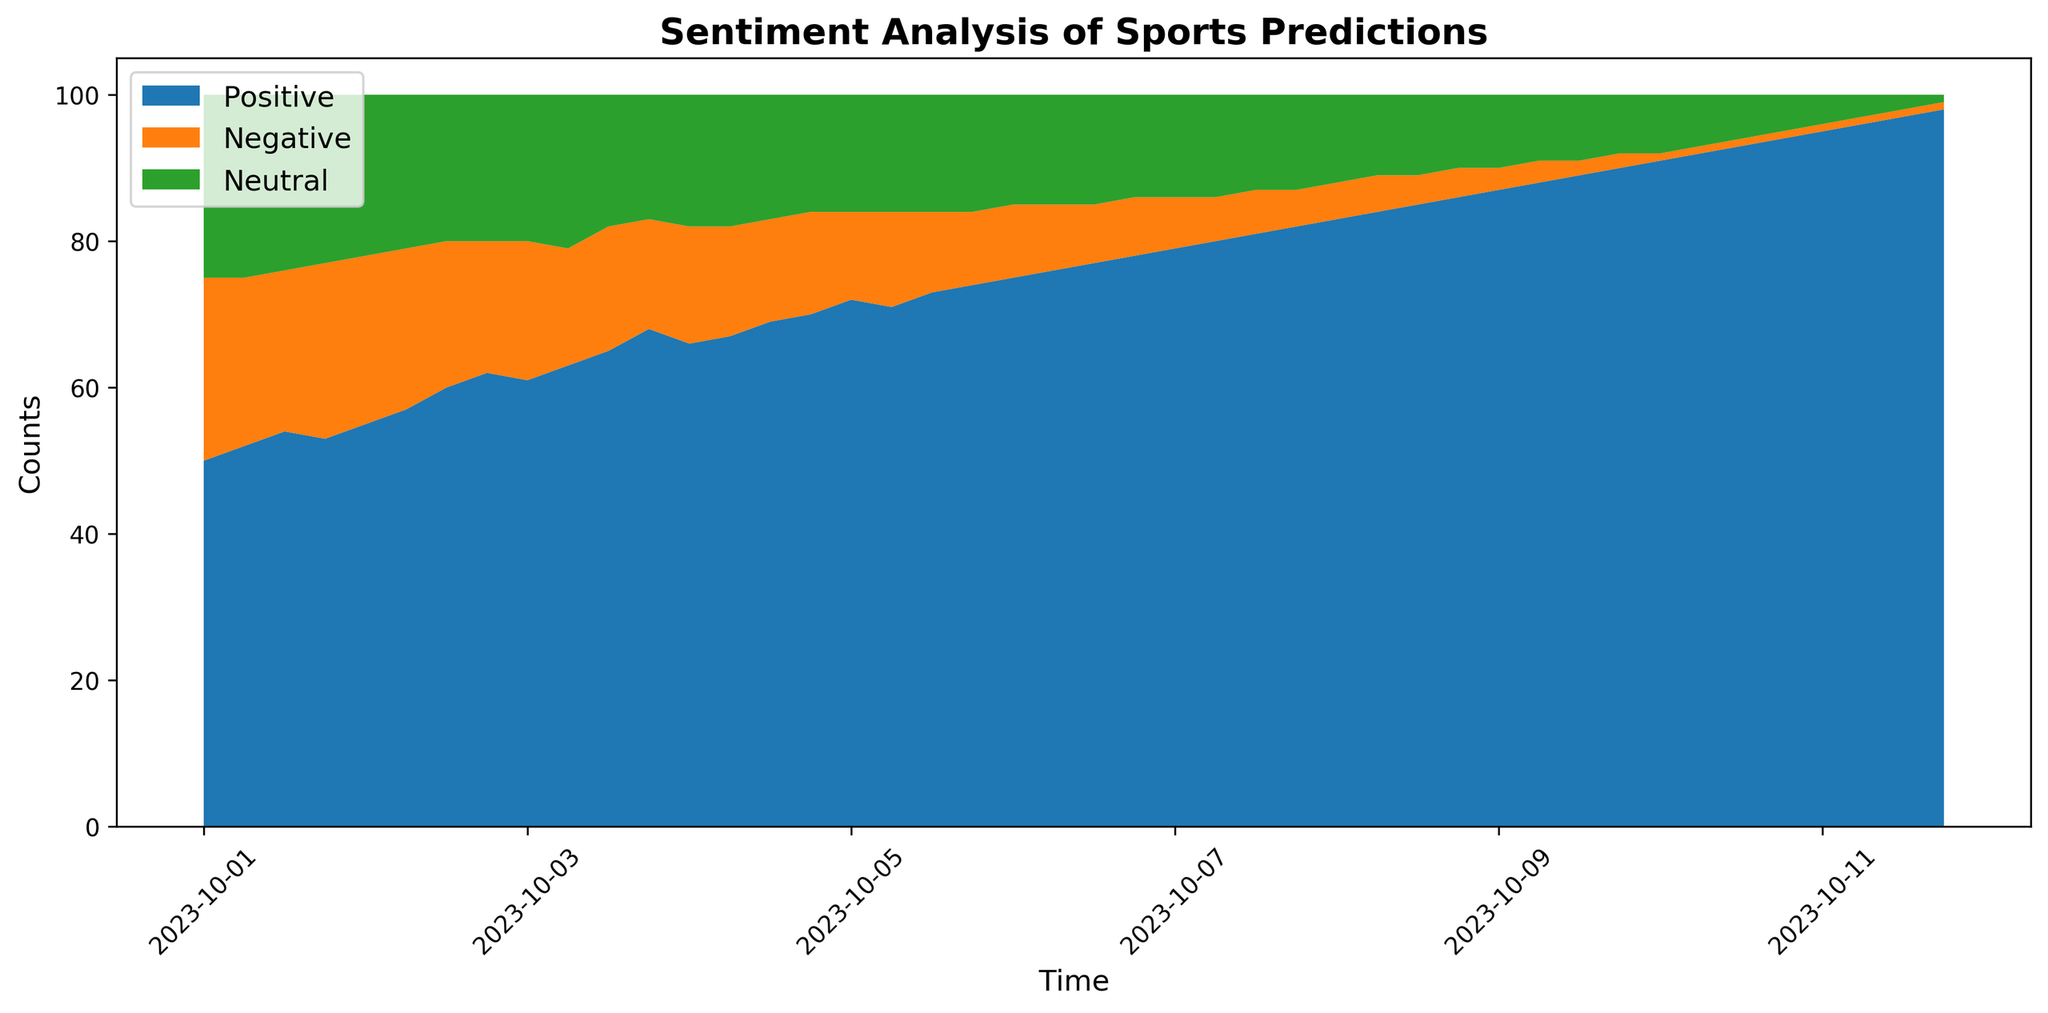What is the overall trend of positive sentiment from October 1 to October 11? The positive sentiment shows a steady increase over time from October 1st to October 11th. You can see that the area representing positive sentiment grows continuously without any significant drops.
Answer: A steady increase Which sentiment (positive, negative, or neutral) shows the least amount of change over time? The neutral sentiment area does not show significant changes and remains relatively constant when compared to the positive and negative sentiments.
Answer: Neutral sentiment At what point in time do the positive and negative sentiments visually show the greatest difference? The greatest difference in visual area between positive and negative sentiments occurs towards the end of the dataset, around October 11th. At this point, the positive sentiment is at its maximum while the negative sentiment is at its minimum.
Answer: Around October 11th During which time period does the neutral sentiment start to decrease more significantly? From the visual plot, starting around October 3rd, the neutral sentiment starts to show a more noticeable decrease compared to previous periods. This can be deduced from the shrinkage of the green area (neutral) in the plot.
Answer: Around October 3rd How do the positive and negative sentiments compare at the beginning and end of the data period? At the beginning of the data period on October 1, the positive sentiment is at 50, and the negative sentiment is at 25. By the end of the data period on October 11, the positive sentiment increases substantially to 98, while the negative sentiment decreases significantly to 1. This illustrates a drastic shift over the time period.
Answer: Positive increased, Negative decreased What is the maximum value reached by the positive sentiment during the recorded time period? The maximum value reached by the positive sentiment is 98, which occurs on October 11th at 18:00. This is visible at the top of the blue area towards the end of the chart.
Answer: 98 Between October 5 and October 9, how does the area representing negative sentiment change visually? Visually, the area representing negative sentiment decreases consistently between October 5 and October 9. This can be seen as the orange section shrinks over this time period.
Answer: Decreases consistently What can be inferred about overall public sentiment towards the sports event as the date approaches? As the date approaches (near October 11), the positive sentiment increases significantly, while both negative and neutral sentiments decrease. This suggests a growing positive public sentiment towards the sports event.
Answer: Growing positive sentiment Which time period shows the largest overall combined sentiment (sum of positive, negative, and neutral sentiments)? Every time period shows the same total count of sentiments (100) since sentiments collectively sum to 100 by design in this dataset. This is evident from the stackplot which maintains a constant height.
Answer: Same throughout 